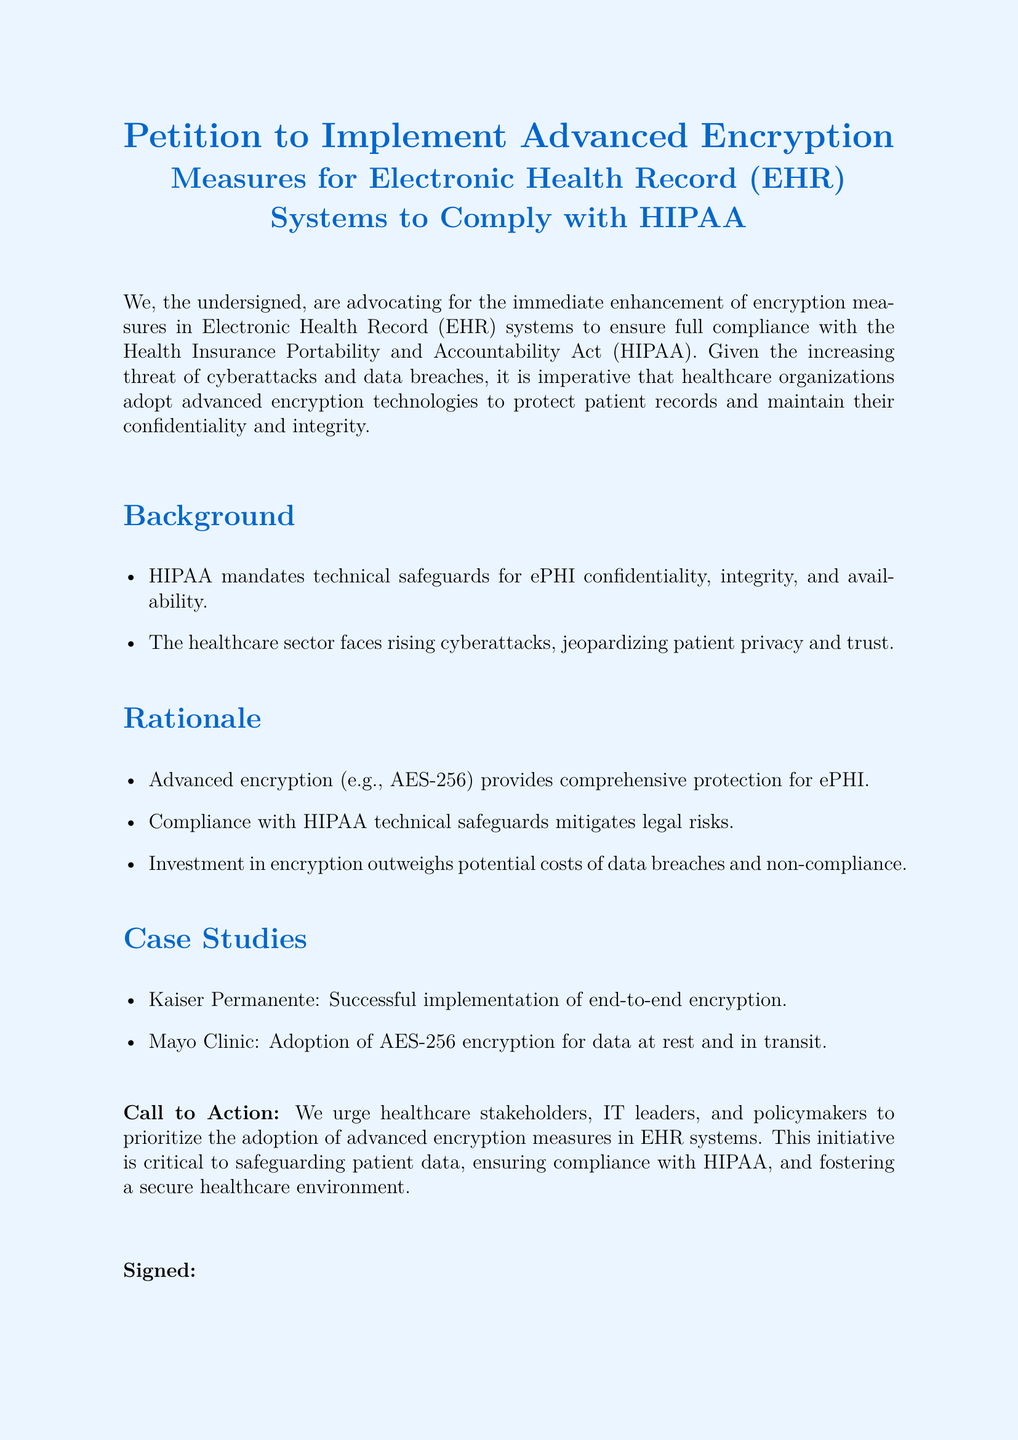What is the title of the petition? The title of the petition is found at the beginning, specifying its purpose and focus on encryption measures in EHR systems.
Answer: Petition to Implement Advanced Encryption Measures for Electronic Health Record (EHR) Systems to Comply with HIPAA What does HIPAA stand for? HIPAA is an acronym mentioned in the document that stands for the Health Insurance Portability and Accountability Act.
Answer: Health Insurance Portability and Accountability Act What encryption standard is mentioned in the rationale? The document discusses an encryption standard that provides comprehensive protection for electronic protected health information (ePHI).
Answer: AES-256 Which organization successfully implemented end-to-end encryption? The document provides a case study example of an organization that has adopted advanced encryption measures effectively.
Answer: Kaiser Permanente What is the main call to action in the petition? The document emphasizes what stakeholders should prioritize to ensure patient data safety and compliance.
Answer: Prioritize the adoption of advanced encryption measures Why is investment in encryption deemed necessary in the petition? The rationale section outlines why investing in encryption is important for healthcare organizations concerning legal and financial implications.
Answer: Investment in encryption outweighs potential costs of data breaches and non-compliance How many case studies are provided in the document? The document includes specific organizational examples to support the call for advanced encryption measures.
Answer: Two What is the purpose of the petition? The document clearly outlines the purpose of the petition in relation to EHR systems and patient data security.
Answer: To ensure full compliance with HIPAA When is the date to be signed on the petition? The document includes a section for signatures, but does not specify a date; it's typically filled out by the signer.
Answer: Date What is required from healthcare stakeholders as per the call to action? The final section specifies what actions are urged from those involved in healthcare to address the issue presented in the petition.
Answer: Adoption of advanced encryption measures 